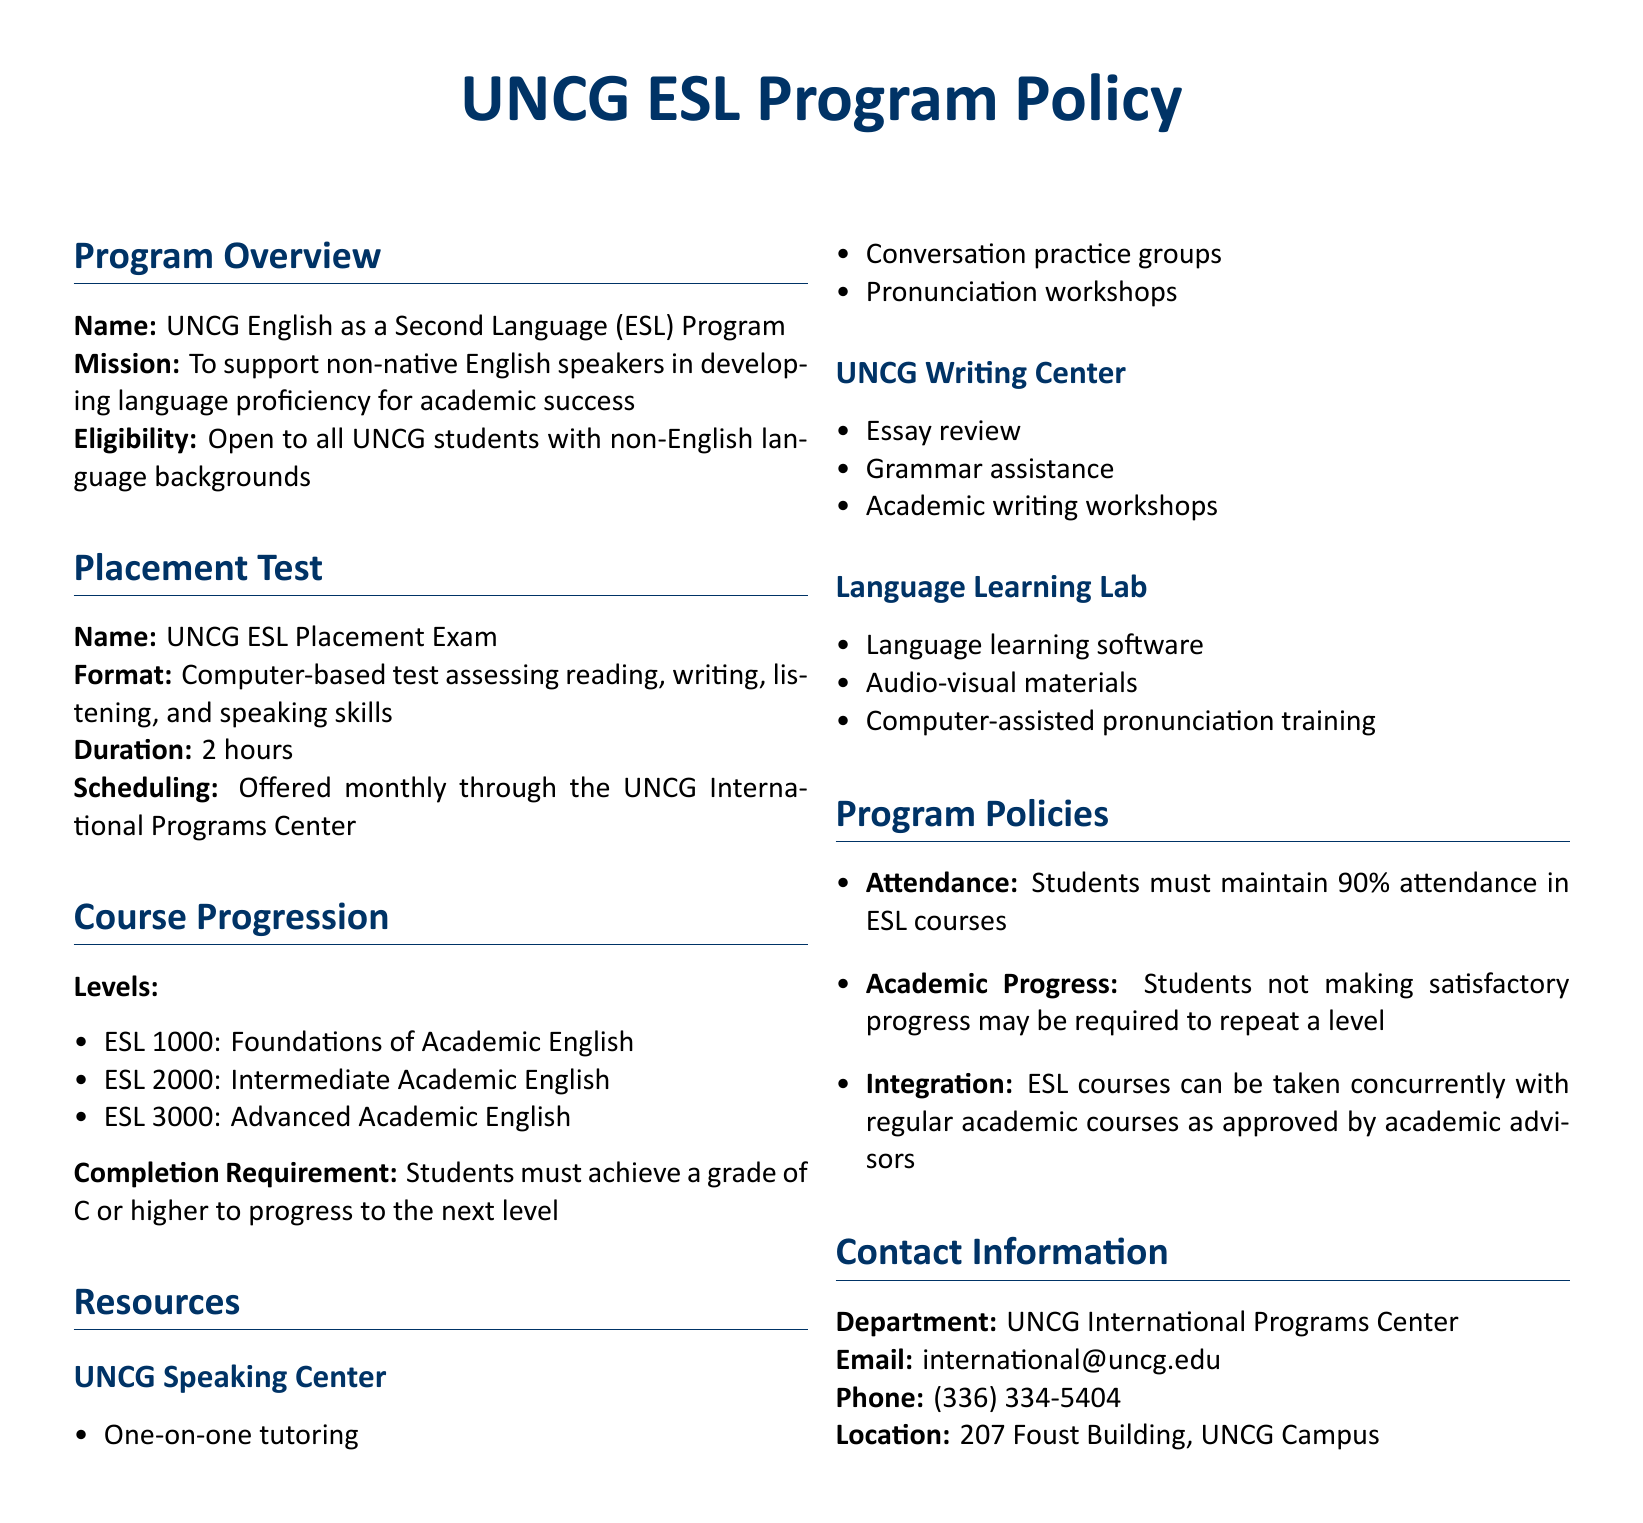what is the name of the program? The first section provides the name of the program as stated in the document.
Answer: UNCG English as a Second Language (ESL) Program what is the format of the placement test? The section regarding the placement test specifies its format clearly.
Answer: Computer-based test how long is the ESL Placement Exam? The duration of the placement test is noted in the document.
Answer: 2 hours what is the completion requirement to progress to the next level? The course progression section outlines the requirement for students to advance in levels.
Answer: Grade of C or higher what resources does the UNCG Speaking Center offer? The resources available at the Speaking Center are listed in the document.
Answer: One-on-one tutoring, conversation practice groups, pronunciation workshops what is the attendance requirement for ESL courses? The program policies section specifies the attendance requirement clearly.
Answer: 90% attendance can ESL courses be taken with regular academic courses? The integration policy indicates whether concurrent enrollment is allowed.
Answer: Yes who can students contact for more information about the ESL program? The contact information section provides details about who to reach out for inquiries.
Answer: UNCG International Programs Center 